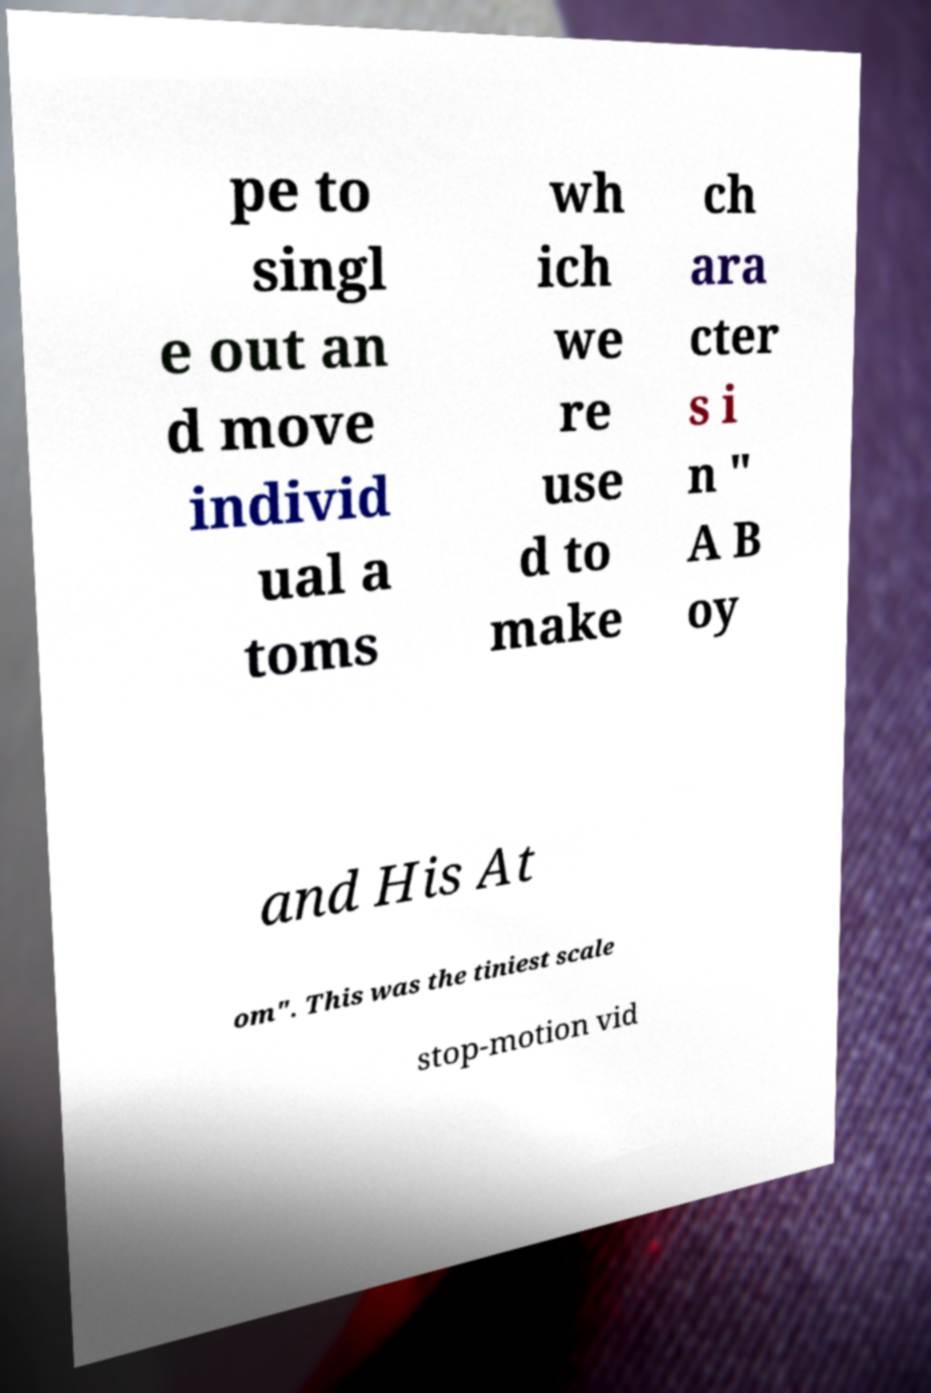Please read and relay the text visible in this image. What does it say? pe to singl e out an d move individ ual a toms wh ich we re use d to make ch ara cter s i n " A B oy and His At om". This was the tiniest scale stop-motion vid 